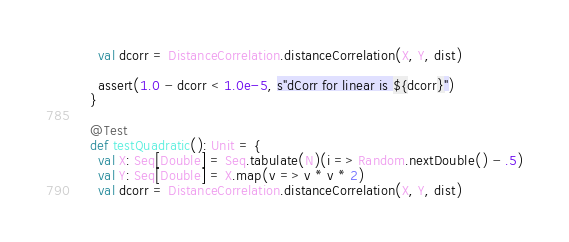Convert code to text. <code><loc_0><loc_0><loc_500><loc_500><_Scala_>    val dcorr = DistanceCorrelation.distanceCorrelation(X, Y, dist)

    assert(1.0 - dcorr < 1.0e-5, s"dCorr for linear is ${dcorr}")
  }

  @Test
  def testQuadratic(): Unit = {
    val X: Seq[Double] = Seq.tabulate(N)(i => Random.nextDouble() - .5)
    val Y: Seq[Double] = X.map(v => v * v * 2)
    val dcorr = DistanceCorrelation.distanceCorrelation(X, Y, dist)
</code> 